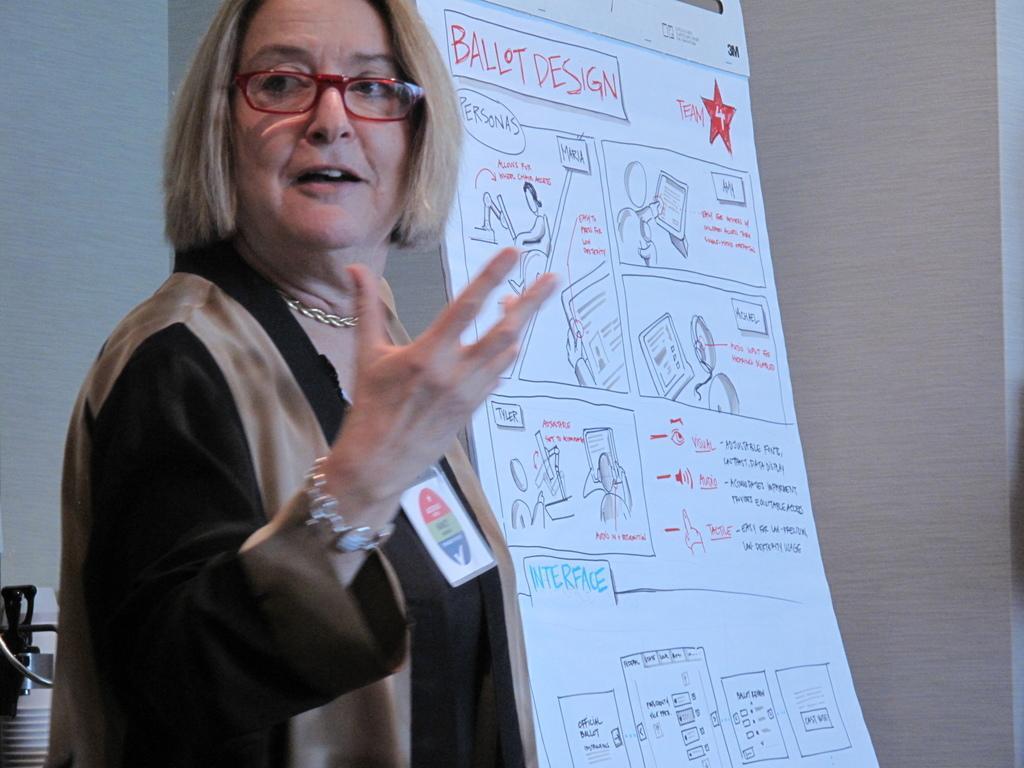Please provide a concise description of this image. In this image, we can see a person wearing spectacles. We can see a board with some images and text. We can see the wall and some objects on the left. 